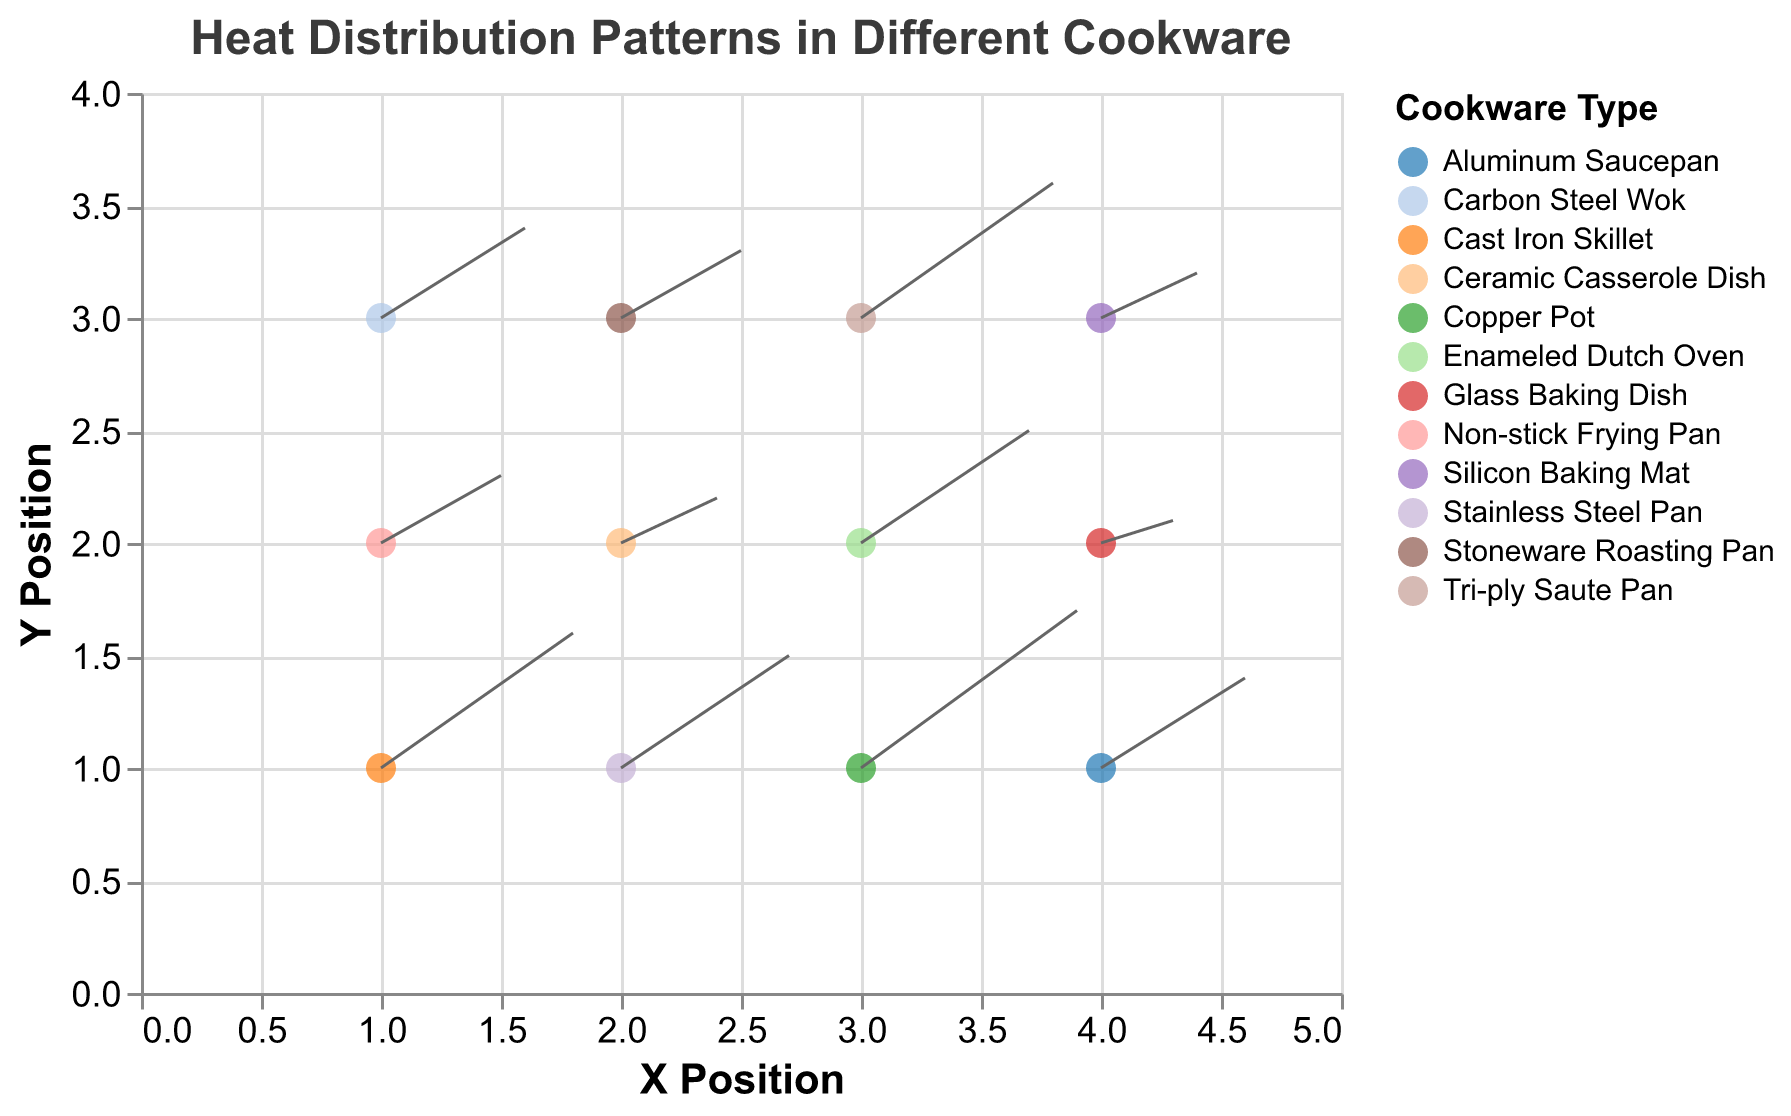What is the title of the plot? The title is usually found at the top of the figure and is readable directly.
Answer: Heat Distribution Patterns in Different Cookware How many types of cookware are represented in the plot? Count the unique items in the legend or from the tooltip information.
Answer: 12 Which type of cookware has the highest heat distribution in the X direction? Identify the point with the highest value for the `u` field, which represents the heat distribution in the X direction.
Answer: Copper Pot Which cookware shows the least heat distribution in both X and Y directions? Look for the cookware with the smallest values of both `u` and `v`.
Answer: Glass Baking Dish Between the Cast Iron Skillet and the Aluminum Saucepan, which one has a higher heat distribution in the Y direction? From the data points, compare the `v` values for both cookwares.
Answer: Cast Iron Skillet What is the average X-axis heat distribution value (`u`) for all cookware types in the third Y position? Filter data points where `y` is 3, then average the `u` values: (0.6 + 0.5 + 0.8 + 0.4) / 4
Answer: 0.575 Which cookware is represented at the coordinates (2, 2)? Identify the cookware from the data point where `x` is 2 and `y` is 2.
Answer: Ceramic Casserole Dish Compare the heat distribution of the Tri-ply Saute Pan and the Non-stick Frying Pan. Which has a greater Y-axis heat distribution? Compare the `v` values of both cookware types.
Answer: Tri-ply Saute Pan How does the heat distribution in the X direction for the Carbon Steel Wok compare to the Stainless Steel Pan? Compare the `u` values of the Carbon Steel Wok and the Stainless Steel Pan.
Answer: Carbon Steel Wok What is the sum of the Y-axis heat distribution (`v` values) for the Cast Iron Skillet and the Enameled Dutch Oven? Add the `v` values of the Cast Iron Skillet and the Enameled Dutch Oven: 0.6 + 0.5
Answer: 1.1 